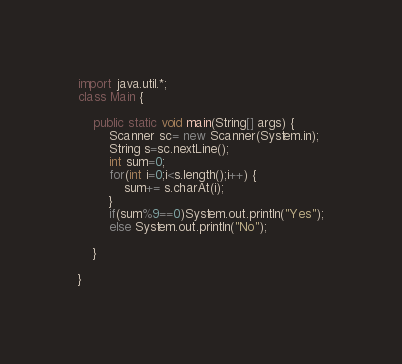Convert code to text. <code><loc_0><loc_0><loc_500><loc_500><_Java_>import java.util.*;
class Main {

	public static void main(String[] args) {
		Scanner sc= new Scanner(System.in);
		String s=sc.nextLine();
		int sum=0;
		for(int i=0;i<s.length();i++) {
			sum+= s.charAt(i);
		}
		if(sum%9==0)System.out.println("Yes");
		else System.out.println("No");

	}

}
</code> 